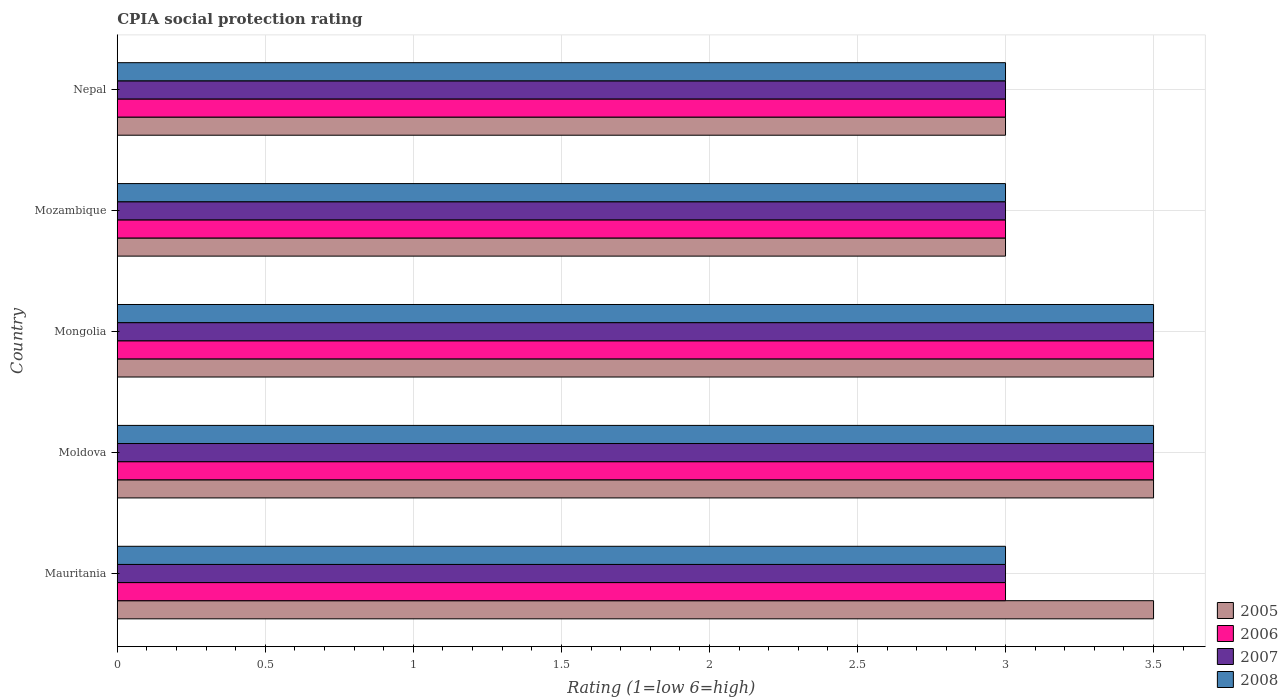How many different coloured bars are there?
Your answer should be compact. 4. How many bars are there on the 2nd tick from the bottom?
Give a very brief answer. 4. What is the label of the 4th group of bars from the top?
Make the answer very short. Moldova. Across all countries, what is the maximum CPIA rating in 2007?
Keep it short and to the point. 3.5. Across all countries, what is the minimum CPIA rating in 2006?
Ensure brevity in your answer.  3. In which country was the CPIA rating in 2005 maximum?
Ensure brevity in your answer.  Mauritania. In which country was the CPIA rating in 2007 minimum?
Make the answer very short. Mauritania. What is the difference between the CPIA rating in 2008 and CPIA rating in 2005 in Mauritania?
Provide a short and direct response. -0.5. What is the ratio of the CPIA rating in 2006 in Moldova to that in Mongolia?
Your response must be concise. 1. Is the difference between the CPIA rating in 2008 in Mauritania and Moldova greater than the difference between the CPIA rating in 2005 in Mauritania and Moldova?
Your response must be concise. No. In how many countries, is the CPIA rating in 2006 greater than the average CPIA rating in 2006 taken over all countries?
Your answer should be very brief. 2. Is the sum of the CPIA rating in 2007 in Mauritania and Mongolia greater than the maximum CPIA rating in 2005 across all countries?
Keep it short and to the point. Yes. Is it the case that in every country, the sum of the CPIA rating in 2008 and CPIA rating in 2006 is greater than the sum of CPIA rating in 2007 and CPIA rating in 2005?
Make the answer very short. No. What does the 4th bar from the top in Mongolia represents?
Keep it short and to the point. 2005. How many countries are there in the graph?
Keep it short and to the point. 5. Are the values on the major ticks of X-axis written in scientific E-notation?
Keep it short and to the point. No. How many legend labels are there?
Your answer should be very brief. 4. How are the legend labels stacked?
Your answer should be very brief. Vertical. What is the title of the graph?
Provide a short and direct response. CPIA social protection rating. What is the label or title of the X-axis?
Provide a succinct answer. Rating (1=low 6=high). What is the label or title of the Y-axis?
Ensure brevity in your answer.  Country. What is the Rating (1=low 6=high) in 2005 in Mauritania?
Offer a very short reply. 3.5. What is the Rating (1=low 6=high) in 2008 in Mauritania?
Provide a succinct answer. 3. What is the Rating (1=low 6=high) of 2005 in Moldova?
Keep it short and to the point. 3.5. What is the Rating (1=low 6=high) in 2007 in Moldova?
Keep it short and to the point. 3.5. What is the Rating (1=low 6=high) of 2008 in Moldova?
Your answer should be very brief. 3.5. What is the Rating (1=low 6=high) of 2008 in Mongolia?
Provide a short and direct response. 3.5. What is the Rating (1=low 6=high) in 2006 in Mozambique?
Give a very brief answer. 3. Across all countries, what is the maximum Rating (1=low 6=high) of 2005?
Give a very brief answer. 3.5. Across all countries, what is the maximum Rating (1=low 6=high) of 2008?
Your response must be concise. 3.5. Across all countries, what is the minimum Rating (1=low 6=high) in 2006?
Provide a short and direct response. 3. Across all countries, what is the minimum Rating (1=low 6=high) of 2008?
Keep it short and to the point. 3. What is the total Rating (1=low 6=high) of 2005 in the graph?
Your answer should be very brief. 16.5. What is the total Rating (1=low 6=high) in 2008 in the graph?
Provide a short and direct response. 16. What is the difference between the Rating (1=low 6=high) of 2005 in Mauritania and that in Moldova?
Ensure brevity in your answer.  0. What is the difference between the Rating (1=low 6=high) in 2006 in Mauritania and that in Moldova?
Keep it short and to the point. -0.5. What is the difference between the Rating (1=low 6=high) in 2007 in Mauritania and that in Moldova?
Give a very brief answer. -0.5. What is the difference between the Rating (1=low 6=high) in 2008 in Mauritania and that in Moldova?
Offer a terse response. -0.5. What is the difference between the Rating (1=low 6=high) of 2005 in Mauritania and that in Mongolia?
Ensure brevity in your answer.  0. What is the difference between the Rating (1=low 6=high) in 2008 in Mauritania and that in Mozambique?
Ensure brevity in your answer.  0. What is the difference between the Rating (1=low 6=high) of 2005 in Mauritania and that in Nepal?
Make the answer very short. 0.5. What is the difference between the Rating (1=low 6=high) of 2008 in Mauritania and that in Nepal?
Offer a very short reply. 0. What is the difference between the Rating (1=low 6=high) in 2008 in Moldova and that in Mongolia?
Your answer should be compact. 0. What is the difference between the Rating (1=low 6=high) of 2005 in Moldova and that in Mozambique?
Ensure brevity in your answer.  0.5. What is the difference between the Rating (1=low 6=high) in 2006 in Moldova and that in Mozambique?
Provide a succinct answer. 0.5. What is the difference between the Rating (1=low 6=high) in 2006 in Moldova and that in Nepal?
Offer a very short reply. 0.5. What is the difference between the Rating (1=low 6=high) of 2007 in Moldova and that in Nepal?
Offer a terse response. 0.5. What is the difference between the Rating (1=low 6=high) in 2005 in Mongolia and that in Mozambique?
Ensure brevity in your answer.  0.5. What is the difference between the Rating (1=low 6=high) in 2006 in Mongolia and that in Mozambique?
Ensure brevity in your answer.  0.5. What is the difference between the Rating (1=low 6=high) in 2007 in Mongolia and that in Mozambique?
Provide a short and direct response. 0.5. What is the difference between the Rating (1=low 6=high) in 2005 in Mongolia and that in Nepal?
Make the answer very short. 0.5. What is the difference between the Rating (1=low 6=high) of 2007 in Mongolia and that in Nepal?
Your answer should be compact. 0.5. What is the difference between the Rating (1=low 6=high) of 2008 in Mongolia and that in Nepal?
Your response must be concise. 0.5. What is the difference between the Rating (1=low 6=high) of 2005 in Mozambique and that in Nepal?
Keep it short and to the point. 0. What is the difference between the Rating (1=low 6=high) in 2006 in Mozambique and that in Nepal?
Your answer should be compact. 0. What is the difference between the Rating (1=low 6=high) of 2007 in Mozambique and that in Nepal?
Your response must be concise. 0. What is the difference between the Rating (1=low 6=high) of 2005 in Mauritania and the Rating (1=low 6=high) of 2008 in Moldova?
Provide a short and direct response. 0. What is the difference between the Rating (1=low 6=high) in 2006 in Mauritania and the Rating (1=low 6=high) in 2007 in Moldova?
Provide a short and direct response. -0.5. What is the difference between the Rating (1=low 6=high) in 2005 in Mauritania and the Rating (1=low 6=high) in 2007 in Mongolia?
Keep it short and to the point. 0. What is the difference between the Rating (1=low 6=high) in 2005 in Mauritania and the Rating (1=low 6=high) in 2008 in Mongolia?
Your answer should be very brief. 0. What is the difference between the Rating (1=low 6=high) in 2006 in Mauritania and the Rating (1=low 6=high) in 2008 in Mongolia?
Your answer should be very brief. -0.5. What is the difference between the Rating (1=low 6=high) of 2005 in Mauritania and the Rating (1=low 6=high) of 2007 in Mozambique?
Keep it short and to the point. 0.5. What is the difference between the Rating (1=low 6=high) of 2007 in Mauritania and the Rating (1=low 6=high) of 2008 in Mozambique?
Offer a terse response. 0. What is the difference between the Rating (1=low 6=high) in 2005 in Mauritania and the Rating (1=low 6=high) in 2006 in Nepal?
Ensure brevity in your answer.  0.5. What is the difference between the Rating (1=low 6=high) of 2005 in Mauritania and the Rating (1=low 6=high) of 2008 in Nepal?
Ensure brevity in your answer.  0.5. What is the difference between the Rating (1=low 6=high) in 2006 in Mauritania and the Rating (1=low 6=high) in 2008 in Nepal?
Provide a short and direct response. 0. What is the difference between the Rating (1=low 6=high) of 2005 in Moldova and the Rating (1=low 6=high) of 2008 in Mongolia?
Offer a terse response. 0. What is the difference between the Rating (1=low 6=high) of 2006 in Moldova and the Rating (1=low 6=high) of 2008 in Mongolia?
Ensure brevity in your answer.  0. What is the difference between the Rating (1=low 6=high) of 2005 in Moldova and the Rating (1=low 6=high) of 2006 in Mozambique?
Your answer should be very brief. 0.5. What is the difference between the Rating (1=low 6=high) in 2005 in Moldova and the Rating (1=low 6=high) in 2006 in Nepal?
Ensure brevity in your answer.  0.5. What is the difference between the Rating (1=low 6=high) in 2005 in Moldova and the Rating (1=low 6=high) in 2007 in Nepal?
Your response must be concise. 0.5. What is the difference between the Rating (1=low 6=high) of 2007 in Moldova and the Rating (1=low 6=high) of 2008 in Nepal?
Ensure brevity in your answer.  0.5. What is the difference between the Rating (1=low 6=high) in 2005 in Mongolia and the Rating (1=low 6=high) in 2007 in Mozambique?
Keep it short and to the point. 0.5. What is the difference between the Rating (1=low 6=high) in 2007 in Mongolia and the Rating (1=low 6=high) in 2008 in Nepal?
Keep it short and to the point. 0.5. What is the difference between the Rating (1=low 6=high) of 2005 in Mozambique and the Rating (1=low 6=high) of 2007 in Nepal?
Ensure brevity in your answer.  0. What is the difference between the Rating (1=low 6=high) in 2006 in Mozambique and the Rating (1=low 6=high) in 2008 in Nepal?
Offer a very short reply. 0. What is the difference between the Rating (1=low 6=high) of 2007 in Mozambique and the Rating (1=low 6=high) of 2008 in Nepal?
Your response must be concise. 0. What is the average Rating (1=low 6=high) in 2006 per country?
Ensure brevity in your answer.  3.2. What is the average Rating (1=low 6=high) of 2007 per country?
Ensure brevity in your answer.  3.2. What is the difference between the Rating (1=low 6=high) in 2005 and Rating (1=low 6=high) in 2006 in Mauritania?
Give a very brief answer. 0.5. What is the difference between the Rating (1=low 6=high) in 2005 and Rating (1=low 6=high) in 2007 in Mauritania?
Give a very brief answer. 0.5. What is the difference between the Rating (1=low 6=high) in 2005 and Rating (1=low 6=high) in 2008 in Mauritania?
Your answer should be very brief. 0.5. What is the difference between the Rating (1=low 6=high) in 2006 and Rating (1=low 6=high) in 2008 in Mauritania?
Your response must be concise. 0. What is the difference between the Rating (1=low 6=high) in 2007 and Rating (1=low 6=high) in 2008 in Mauritania?
Make the answer very short. 0. What is the difference between the Rating (1=low 6=high) of 2006 and Rating (1=low 6=high) of 2007 in Moldova?
Ensure brevity in your answer.  0. What is the difference between the Rating (1=low 6=high) in 2007 and Rating (1=low 6=high) in 2008 in Moldova?
Provide a short and direct response. 0. What is the difference between the Rating (1=low 6=high) in 2005 and Rating (1=low 6=high) in 2006 in Mongolia?
Offer a terse response. 0. What is the difference between the Rating (1=low 6=high) in 2006 and Rating (1=low 6=high) in 2007 in Mongolia?
Make the answer very short. 0. What is the difference between the Rating (1=low 6=high) in 2006 and Rating (1=low 6=high) in 2008 in Mongolia?
Give a very brief answer. 0. What is the difference between the Rating (1=low 6=high) of 2007 and Rating (1=low 6=high) of 2008 in Mongolia?
Your answer should be very brief. 0. What is the difference between the Rating (1=low 6=high) in 2005 and Rating (1=low 6=high) in 2006 in Mozambique?
Your answer should be compact. 0. What is the difference between the Rating (1=low 6=high) in 2005 and Rating (1=low 6=high) in 2007 in Mozambique?
Your answer should be very brief. 0. What is the difference between the Rating (1=low 6=high) of 2005 and Rating (1=low 6=high) of 2008 in Mozambique?
Your answer should be compact. 0. What is the difference between the Rating (1=low 6=high) of 2007 and Rating (1=low 6=high) of 2008 in Mozambique?
Provide a short and direct response. 0. What is the difference between the Rating (1=low 6=high) of 2005 and Rating (1=low 6=high) of 2007 in Nepal?
Give a very brief answer. 0. What is the difference between the Rating (1=low 6=high) of 2006 and Rating (1=low 6=high) of 2008 in Nepal?
Keep it short and to the point. 0. What is the ratio of the Rating (1=low 6=high) in 2005 in Mauritania to that in Moldova?
Your answer should be very brief. 1. What is the ratio of the Rating (1=low 6=high) in 2007 in Mauritania to that in Mongolia?
Give a very brief answer. 0.86. What is the ratio of the Rating (1=low 6=high) of 2007 in Mauritania to that in Mozambique?
Make the answer very short. 1. What is the ratio of the Rating (1=low 6=high) of 2007 in Mauritania to that in Nepal?
Offer a very short reply. 1. What is the ratio of the Rating (1=low 6=high) of 2005 in Moldova to that in Mongolia?
Keep it short and to the point. 1. What is the ratio of the Rating (1=low 6=high) of 2007 in Moldova to that in Mongolia?
Your response must be concise. 1. What is the ratio of the Rating (1=low 6=high) of 2007 in Moldova to that in Mozambique?
Give a very brief answer. 1.17. What is the ratio of the Rating (1=low 6=high) in 2008 in Moldova to that in Mozambique?
Your response must be concise. 1.17. What is the ratio of the Rating (1=low 6=high) in 2006 in Moldova to that in Nepal?
Your answer should be very brief. 1.17. What is the ratio of the Rating (1=low 6=high) of 2007 in Moldova to that in Nepal?
Your response must be concise. 1.17. What is the ratio of the Rating (1=low 6=high) of 2008 in Moldova to that in Nepal?
Your answer should be compact. 1.17. What is the ratio of the Rating (1=low 6=high) of 2005 in Mongolia to that in Mozambique?
Keep it short and to the point. 1.17. What is the ratio of the Rating (1=low 6=high) in 2006 in Mongolia to that in Mozambique?
Give a very brief answer. 1.17. What is the ratio of the Rating (1=low 6=high) of 2007 in Mongolia to that in Mozambique?
Ensure brevity in your answer.  1.17. What is the ratio of the Rating (1=low 6=high) of 2008 in Mongolia to that in Nepal?
Keep it short and to the point. 1.17. What is the ratio of the Rating (1=low 6=high) in 2006 in Mozambique to that in Nepal?
Provide a succinct answer. 1. What is the ratio of the Rating (1=low 6=high) of 2007 in Mozambique to that in Nepal?
Your answer should be very brief. 1. What is the ratio of the Rating (1=low 6=high) in 2008 in Mozambique to that in Nepal?
Offer a terse response. 1. What is the difference between the highest and the second highest Rating (1=low 6=high) in 2006?
Your answer should be compact. 0. What is the difference between the highest and the second highest Rating (1=low 6=high) in 2007?
Provide a succinct answer. 0. What is the difference between the highest and the lowest Rating (1=low 6=high) of 2008?
Your answer should be compact. 0.5. 